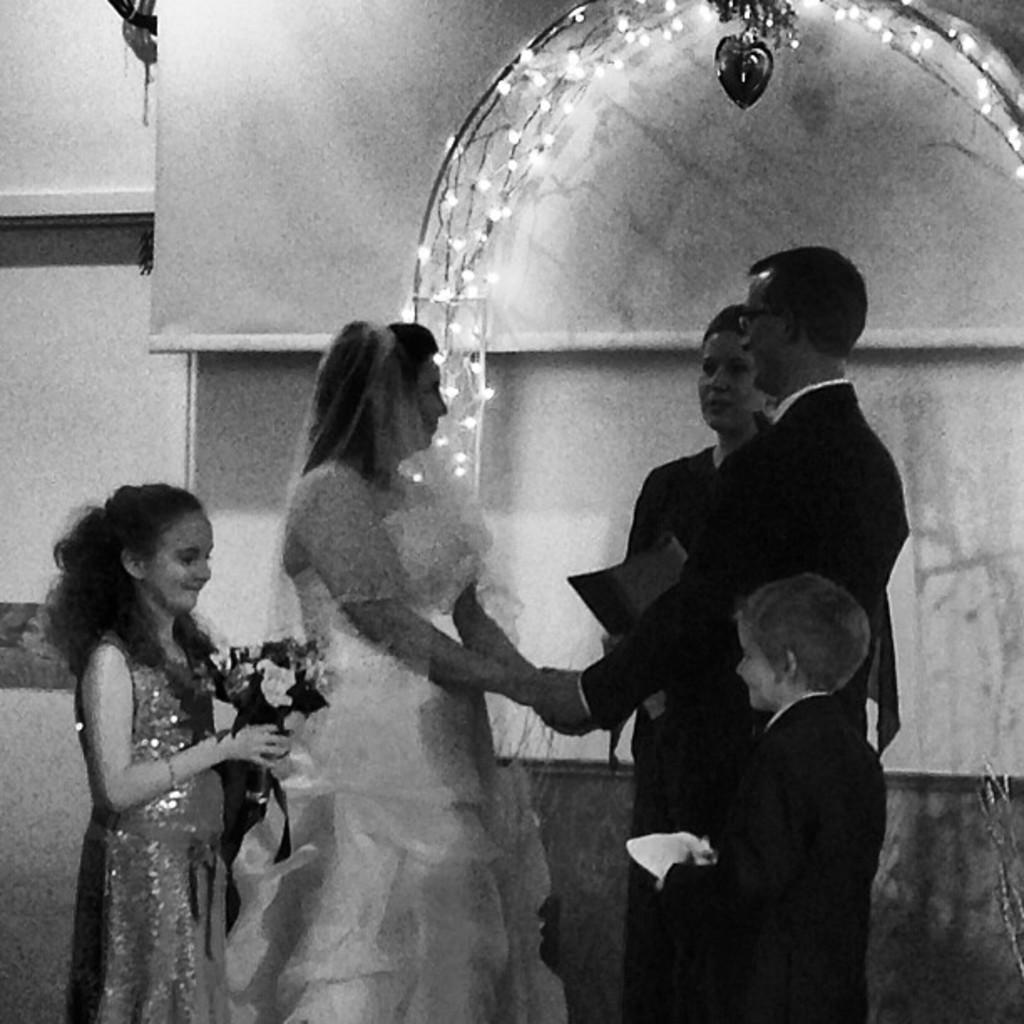What is happening in the image? There is a group of people standing in the image. What can be observed about the people's attire? The people are wearing clothes. Where are the people standing in relation to the wall? The people are standing beside a wall. Can you describe the child's position and action in the image? The kid is in the bottom left of the image and is holding a bouquet with her hands. What type of tree can be seen in the background of the image? There is no tree visible in the background of the image. 